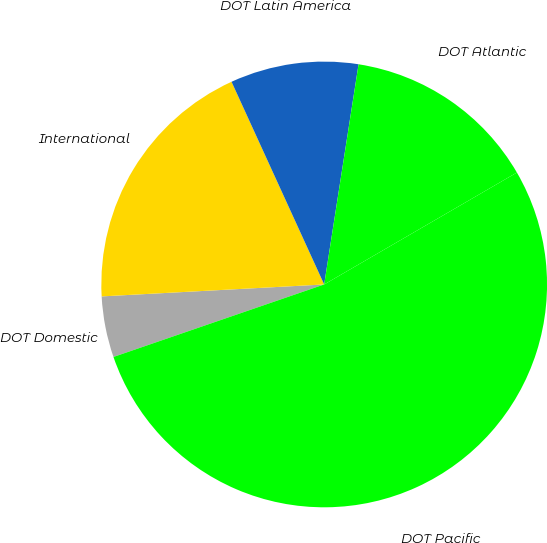<chart> <loc_0><loc_0><loc_500><loc_500><pie_chart><fcel>DOT Domestic<fcel>International<fcel>DOT Latin America<fcel>DOT Atlantic<fcel>DOT Pacific<nl><fcel>4.42%<fcel>19.03%<fcel>9.29%<fcel>14.16%<fcel>53.1%<nl></chart> 